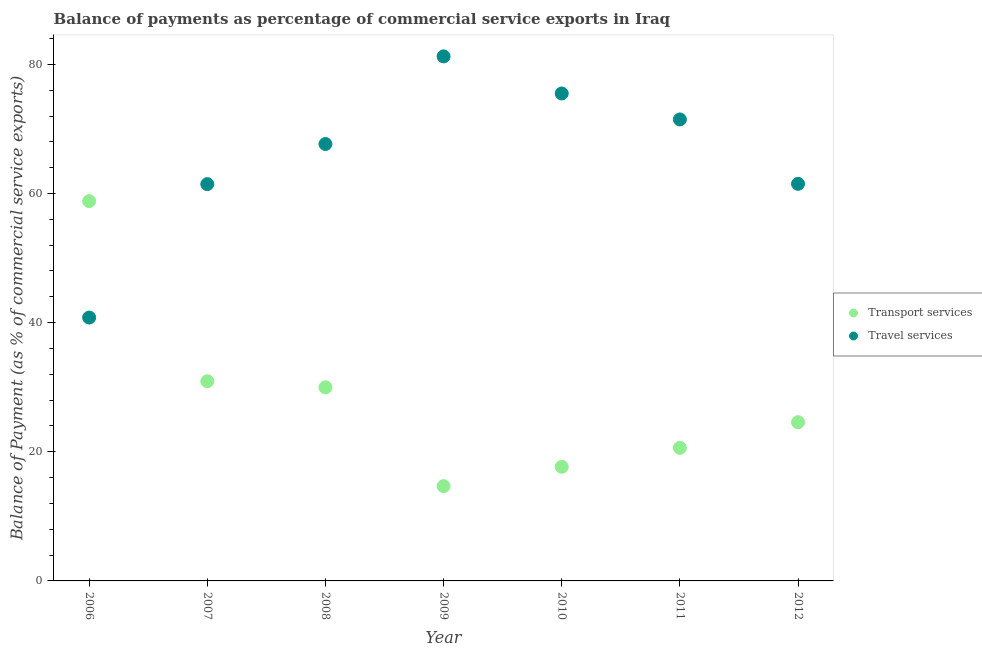What is the balance of payments of transport services in 2007?
Keep it short and to the point. 30.92. Across all years, what is the maximum balance of payments of travel services?
Provide a short and direct response. 81.24. Across all years, what is the minimum balance of payments of travel services?
Make the answer very short. 40.79. In which year was the balance of payments of transport services maximum?
Provide a succinct answer. 2006. In which year was the balance of payments of travel services minimum?
Your response must be concise. 2006. What is the total balance of payments of travel services in the graph?
Provide a short and direct response. 459.59. What is the difference between the balance of payments of transport services in 2007 and that in 2010?
Offer a very short reply. 13.25. What is the difference between the balance of payments of travel services in 2010 and the balance of payments of transport services in 2006?
Ensure brevity in your answer.  16.67. What is the average balance of payments of travel services per year?
Your response must be concise. 65.66. In the year 2012, what is the difference between the balance of payments of transport services and balance of payments of travel services?
Your answer should be very brief. -36.92. What is the ratio of the balance of payments of transport services in 2009 to that in 2011?
Make the answer very short. 0.71. Is the balance of payments of travel services in 2008 less than that in 2012?
Your answer should be very brief. No. What is the difference between the highest and the second highest balance of payments of travel services?
Ensure brevity in your answer.  5.75. What is the difference between the highest and the lowest balance of payments of travel services?
Your answer should be very brief. 40.45. Does the balance of payments of travel services monotonically increase over the years?
Your response must be concise. No. Is the balance of payments of transport services strictly greater than the balance of payments of travel services over the years?
Your answer should be compact. No. What is the difference between two consecutive major ticks on the Y-axis?
Provide a short and direct response. 20. Are the values on the major ticks of Y-axis written in scientific E-notation?
Provide a succinct answer. No. Does the graph contain any zero values?
Offer a very short reply. No. Where does the legend appear in the graph?
Ensure brevity in your answer.  Center right. What is the title of the graph?
Provide a succinct answer. Balance of payments as percentage of commercial service exports in Iraq. What is the label or title of the X-axis?
Give a very brief answer. Year. What is the label or title of the Y-axis?
Your response must be concise. Balance of Payment (as % of commercial service exports). What is the Balance of Payment (as % of commercial service exports) in Transport services in 2006?
Offer a terse response. 58.82. What is the Balance of Payment (as % of commercial service exports) in Travel services in 2006?
Provide a succinct answer. 40.79. What is the Balance of Payment (as % of commercial service exports) in Transport services in 2007?
Give a very brief answer. 30.92. What is the Balance of Payment (as % of commercial service exports) of Travel services in 2007?
Provide a succinct answer. 61.45. What is the Balance of Payment (as % of commercial service exports) of Transport services in 2008?
Keep it short and to the point. 29.98. What is the Balance of Payment (as % of commercial service exports) in Travel services in 2008?
Ensure brevity in your answer.  67.66. What is the Balance of Payment (as % of commercial service exports) in Transport services in 2009?
Give a very brief answer. 14.68. What is the Balance of Payment (as % of commercial service exports) in Travel services in 2009?
Ensure brevity in your answer.  81.24. What is the Balance of Payment (as % of commercial service exports) of Transport services in 2010?
Make the answer very short. 17.68. What is the Balance of Payment (as % of commercial service exports) of Travel services in 2010?
Your response must be concise. 75.49. What is the Balance of Payment (as % of commercial service exports) of Transport services in 2011?
Provide a short and direct response. 20.61. What is the Balance of Payment (as % of commercial service exports) of Travel services in 2011?
Provide a succinct answer. 71.47. What is the Balance of Payment (as % of commercial service exports) in Transport services in 2012?
Offer a very short reply. 24.58. What is the Balance of Payment (as % of commercial service exports) of Travel services in 2012?
Offer a very short reply. 61.5. Across all years, what is the maximum Balance of Payment (as % of commercial service exports) in Transport services?
Your answer should be very brief. 58.82. Across all years, what is the maximum Balance of Payment (as % of commercial service exports) of Travel services?
Your response must be concise. 81.24. Across all years, what is the minimum Balance of Payment (as % of commercial service exports) in Transport services?
Ensure brevity in your answer.  14.68. Across all years, what is the minimum Balance of Payment (as % of commercial service exports) in Travel services?
Provide a short and direct response. 40.79. What is the total Balance of Payment (as % of commercial service exports) in Transport services in the graph?
Provide a succinct answer. 197.27. What is the total Balance of Payment (as % of commercial service exports) in Travel services in the graph?
Provide a succinct answer. 459.59. What is the difference between the Balance of Payment (as % of commercial service exports) in Transport services in 2006 and that in 2007?
Your response must be concise. 27.89. What is the difference between the Balance of Payment (as % of commercial service exports) of Travel services in 2006 and that in 2007?
Offer a terse response. -20.66. What is the difference between the Balance of Payment (as % of commercial service exports) in Transport services in 2006 and that in 2008?
Make the answer very short. 28.83. What is the difference between the Balance of Payment (as % of commercial service exports) in Travel services in 2006 and that in 2008?
Ensure brevity in your answer.  -26.88. What is the difference between the Balance of Payment (as % of commercial service exports) of Transport services in 2006 and that in 2009?
Make the answer very short. 44.13. What is the difference between the Balance of Payment (as % of commercial service exports) of Travel services in 2006 and that in 2009?
Offer a very short reply. -40.45. What is the difference between the Balance of Payment (as % of commercial service exports) in Transport services in 2006 and that in 2010?
Provide a succinct answer. 41.14. What is the difference between the Balance of Payment (as % of commercial service exports) in Travel services in 2006 and that in 2010?
Make the answer very short. -34.7. What is the difference between the Balance of Payment (as % of commercial service exports) of Transport services in 2006 and that in 2011?
Give a very brief answer. 38.21. What is the difference between the Balance of Payment (as % of commercial service exports) in Travel services in 2006 and that in 2011?
Give a very brief answer. -30.68. What is the difference between the Balance of Payment (as % of commercial service exports) of Transport services in 2006 and that in 2012?
Your response must be concise. 34.24. What is the difference between the Balance of Payment (as % of commercial service exports) of Travel services in 2006 and that in 2012?
Keep it short and to the point. -20.71. What is the difference between the Balance of Payment (as % of commercial service exports) in Transport services in 2007 and that in 2008?
Keep it short and to the point. 0.94. What is the difference between the Balance of Payment (as % of commercial service exports) of Travel services in 2007 and that in 2008?
Your answer should be very brief. -6.21. What is the difference between the Balance of Payment (as % of commercial service exports) in Transport services in 2007 and that in 2009?
Provide a short and direct response. 16.24. What is the difference between the Balance of Payment (as % of commercial service exports) of Travel services in 2007 and that in 2009?
Offer a terse response. -19.79. What is the difference between the Balance of Payment (as % of commercial service exports) in Transport services in 2007 and that in 2010?
Your response must be concise. 13.25. What is the difference between the Balance of Payment (as % of commercial service exports) in Travel services in 2007 and that in 2010?
Keep it short and to the point. -14.04. What is the difference between the Balance of Payment (as % of commercial service exports) of Transport services in 2007 and that in 2011?
Ensure brevity in your answer.  10.31. What is the difference between the Balance of Payment (as % of commercial service exports) of Travel services in 2007 and that in 2011?
Keep it short and to the point. -10.02. What is the difference between the Balance of Payment (as % of commercial service exports) in Transport services in 2007 and that in 2012?
Provide a succinct answer. 6.35. What is the difference between the Balance of Payment (as % of commercial service exports) of Travel services in 2007 and that in 2012?
Provide a succinct answer. -0.05. What is the difference between the Balance of Payment (as % of commercial service exports) in Transport services in 2008 and that in 2009?
Offer a very short reply. 15.3. What is the difference between the Balance of Payment (as % of commercial service exports) of Travel services in 2008 and that in 2009?
Make the answer very short. -13.57. What is the difference between the Balance of Payment (as % of commercial service exports) in Transport services in 2008 and that in 2010?
Ensure brevity in your answer.  12.31. What is the difference between the Balance of Payment (as % of commercial service exports) of Travel services in 2008 and that in 2010?
Your response must be concise. -7.83. What is the difference between the Balance of Payment (as % of commercial service exports) of Transport services in 2008 and that in 2011?
Provide a succinct answer. 9.37. What is the difference between the Balance of Payment (as % of commercial service exports) of Travel services in 2008 and that in 2011?
Provide a short and direct response. -3.81. What is the difference between the Balance of Payment (as % of commercial service exports) in Transport services in 2008 and that in 2012?
Keep it short and to the point. 5.41. What is the difference between the Balance of Payment (as % of commercial service exports) of Travel services in 2008 and that in 2012?
Your response must be concise. 6.16. What is the difference between the Balance of Payment (as % of commercial service exports) of Transport services in 2009 and that in 2010?
Ensure brevity in your answer.  -2.99. What is the difference between the Balance of Payment (as % of commercial service exports) of Travel services in 2009 and that in 2010?
Offer a terse response. 5.75. What is the difference between the Balance of Payment (as % of commercial service exports) in Transport services in 2009 and that in 2011?
Keep it short and to the point. -5.93. What is the difference between the Balance of Payment (as % of commercial service exports) of Travel services in 2009 and that in 2011?
Your answer should be compact. 9.77. What is the difference between the Balance of Payment (as % of commercial service exports) in Transport services in 2009 and that in 2012?
Make the answer very short. -9.89. What is the difference between the Balance of Payment (as % of commercial service exports) of Travel services in 2009 and that in 2012?
Give a very brief answer. 19.74. What is the difference between the Balance of Payment (as % of commercial service exports) in Transport services in 2010 and that in 2011?
Give a very brief answer. -2.94. What is the difference between the Balance of Payment (as % of commercial service exports) of Travel services in 2010 and that in 2011?
Offer a very short reply. 4.02. What is the difference between the Balance of Payment (as % of commercial service exports) of Transport services in 2010 and that in 2012?
Offer a very short reply. -6.9. What is the difference between the Balance of Payment (as % of commercial service exports) of Travel services in 2010 and that in 2012?
Give a very brief answer. 13.99. What is the difference between the Balance of Payment (as % of commercial service exports) in Transport services in 2011 and that in 2012?
Your answer should be very brief. -3.97. What is the difference between the Balance of Payment (as % of commercial service exports) in Travel services in 2011 and that in 2012?
Provide a short and direct response. 9.97. What is the difference between the Balance of Payment (as % of commercial service exports) in Transport services in 2006 and the Balance of Payment (as % of commercial service exports) in Travel services in 2007?
Give a very brief answer. -2.63. What is the difference between the Balance of Payment (as % of commercial service exports) in Transport services in 2006 and the Balance of Payment (as % of commercial service exports) in Travel services in 2008?
Offer a terse response. -8.85. What is the difference between the Balance of Payment (as % of commercial service exports) in Transport services in 2006 and the Balance of Payment (as % of commercial service exports) in Travel services in 2009?
Offer a terse response. -22.42. What is the difference between the Balance of Payment (as % of commercial service exports) of Transport services in 2006 and the Balance of Payment (as % of commercial service exports) of Travel services in 2010?
Offer a terse response. -16.67. What is the difference between the Balance of Payment (as % of commercial service exports) of Transport services in 2006 and the Balance of Payment (as % of commercial service exports) of Travel services in 2011?
Give a very brief answer. -12.65. What is the difference between the Balance of Payment (as % of commercial service exports) in Transport services in 2006 and the Balance of Payment (as % of commercial service exports) in Travel services in 2012?
Give a very brief answer. -2.68. What is the difference between the Balance of Payment (as % of commercial service exports) of Transport services in 2007 and the Balance of Payment (as % of commercial service exports) of Travel services in 2008?
Your answer should be compact. -36.74. What is the difference between the Balance of Payment (as % of commercial service exports) in Transport services in 2007 and the Balance of Payment (as % of commercial service exports) in Travel services in 2009?
Offer a terse response. -50.31. What is the difference between the Balance of Payment (as % of commercial service exports) of Transport services in 2007 and the Balance of Payment (as % of commercial service exports) of Travel services in 2010?
Your response must be concise. -44.57. What is the difference between the Balance of Payment (as % of commercial service exports) of Transport services in 2007 and the Balance of Payment (as % of commercial service exports) of Travel services in 2011?
Your response must be concise. -40.55. What is the difference between the Balance of Payment (as % of commercial service exports) in Transport services in 2007 and the Balance of Payment (as % of commercial service exports) in Travel services in 2012?
Your answer should be very brief. -30.58. What is the difference between the Balance of Payment (as % of commercial service exports) in Transport services in 2008 and the Balance of Payment (as % of commercial service exports) in Travel services in 2009?
Offer a terse response. -51.25. What is the difference between the Balance of Payment (as % of commercial service exports) of Transport services in 2008 and the Balance of Payment (as % of commercial service exports) of Travel services in 2010?
Keep it short and to the point. -45.51. What is the difference between the Balance of Payment (as % of commercial service exports) of Transport services in 2008 and the Balance of Payment (as % of commercial service exports) of Travel services in 2011?
Your answer should be very brief. -41.48. What is the difference between the Balance of Payment (as % of commercial service exports) in Transport services in 2008 and the Balance of Payment (as % of commercial service exports) in Travel services in 2012?
Make the answer very short. -31.51. What is the difference between the Balance of Payment (as % of commercial service exports) of Transport services in 2009 and the Balance of Payment (as % of commercial service exports) of Travel services in 2010?
Offer a terse response. -60.81. What is the difference between the Balance of Payment (as % of commercial service exports) of Transport services in 2009 and the Balance of Payment (as % of commercial service exports) of Travel services in 2011?
Provide a short and direct response. -56.79. What is the difference between the Balance of Payment (as % of commercial service exports) of Transport services in 2009 and the Balance of Payment (as % of commercial service exports) of Travel services in 2012?
Your answer should be very brief. -46.82. What is the difference between the Balance of Payment (as % of commercial service exports) in Transport services in 2010 and the Balance of Payment (as % of commercial service exports) in Travel services in 2011?
Your answer should be compact. -53.79. What is the difference between the Balance of Payment (as % of commercial service exports) in Transport services in 2010 and the Balance of Payment (as % of commercial service exports) in Travel services in 2012?
Keep it short and to the point. -43.82. What is the difference between the Balance of Payment (as % of commercial service exports) of Transport services in 2011 and the Balance of Payment (as % of commercial service exports) of Travel services in 2012?
Give a very brief answer. -40.89. What is the average Balance of Payment (as % of commercial service exports) of Transport services per year?
Keep it short and to the point. 28.18. What is the average Balance of Payment (as % of commercial service exports) in Travel services per year?
Provide a short and direct response. 65.66. In the year 2006, what is the difference between the Balance of Payment (as % of commercial service exports) of Transport services and Balance of Payment (as % of commercial service exports) of Travel services?
Give a very brief answer. 18.03. In the year 2007, what is the difference between the Balance of Payment (as % of commercial service exports) in Transport services and Balance of Payment (as % of commercial service exports) in Travel services?
Offer a very short reply. -30.53. In the year 2008, what is the difference between the Balance of Payment (as % of commercial service exports) of Transport services and Balance of Payment (as % of commercial service exports) of Travel services?
Your answer should be very brief. -37.68. In the year 2009, what is the difference between the Balance of Payment (as % of commercial service exports) in Transport services and Balance of Payment (as % of commercial service exports) in Travel services?
Give a very brief answer. -66.55. In the year 2010, what is the difference between the Balance of Payment (as % of commercial service exports) in Transport services and Balance of Payment (as % of commercial service exports) in Travel services?
Your response must be concise. -57.81. In the year 2011, what is the difference between the Balance of Payment (as % of commercial service exports) of Transport services and Balance of Payment (as % of commercial service exports) of Travel services?
Offer a very short reply. -50.86. In the year 2012, what is the difference between the Balance of Payment (as % of commercial service exports) in Transport services and Balance of Payment (as % of commercial service exports) in Travel services?
Provide a short and direct response. -36.92. What is the ratio of the Balance of Payment (as % of commercial service exports) in Transport services in 2006 to that in 2007?
Your answer should be compact. 1.9. What is the ratio of the Balance of Payment (as % of commercial service exports) of Travel services in 2006 to that in 2007?
Offer a very short reply. 0.66. What is the ratio of the Balance of Payment (as % of commercial service exports) in Transport services in 2006 to that in 2008?
Keep it short and to the point. 1.96. What is the ratio of the Balance of Payment (as % of commercial service exports) of Travel services in 2006 to that in 2008?
Provide a short and direct response. 0.6. What is the ratio of the Balance of Payment (as % of commercial service exports) of Transport services in 2006 to that in 2009?
Make the answer very short. 4.01. What is the ratio of the Balance of Payment (as % of commercial service exports) of Travel services in 2006 to that in 2009?
Make the answer very short. 0.5. What is the ratio of the Balance of Payment (as % of commercial service exports) of Transport services in 2006 to that in 2010?
Your answer should be very brief. 3.33. What is the ratio of the Balance of Payment (as % of commercial service exports) of Travel services in 2006 to that in 2010?
Offer a terse response. 0.54. What is the ratio of the Balance of Payment (as % of commercial service exports) of Transport services in 2006 to that in 2011?
Your answer should be very brief. 2.85. What is the ratio of the Balance of Payment (as % of commercial service exports) in Travel services in 2006 to that in 2011?
Your answer should be compact. 0.57. What is the ratio of the Balance of Payment (as % of commercial service exports) of Transport services in 2006 to that in 2012?
Give a very brief answer. 2.39. What is the ratio of the Balance of Payment (as % of commercial service exports) in Travel services in 2006 to that in 2012?
Your response must be concise. 0.66. What is the ratio of the Balance of Payment (as % of commercial service exports) in Transport services in 2007 to that in 2008?
Give a very brief answer. 1.03. What is the ratio of the Balance of Payment (as % of commercial service exports) of Travel services in 2007 to that in 2008?
Your response must be concise. 0.91. What is the ratio of the Balance of Payment (as % of commercial service exports) in Transport services in 2007 to that in 2009?
Your response must be concise. 2.11. What is the ratio of the Balance of Payment (as % of commercial service exports) of Travel services in 2007 to that in 2009?
Ensure brevity in your answer.  0.76. What is the ratio of the Balance of Payment (as % of commercial service exports) of Transport services in 2007 to that in 2010?
Make the answer very short. 1.75. What is the ratio of the Balance of Payment (as % of commercial service exports) in Travel services in 2007 to that in 2010?
Give a very brief answer. 0.81. What is the ratio of the Balance of Payment (as % of commercial service exports) in Transport services in 2007 to that in 2011?
Offer a terse response. 1.5. What is the ratio of the Balance of Payment (as % of commercial service exports) of Travel services in 2007 to that in 2011?
Your answer should be very brief. 0.86. What is the ratio of the Balance of Payment (as % of commercial service exports) in Transport services in 2007 to that in 2012?
Your response must be concise. 1.26. What is the ratio of the Balance of Payment (as % of commercial service exports) of Travel services in 2007 to that in 2012?
Make the answer very short. 1. What is the ratio of the Balance of Payment (as % of commercial service exports) of Transport services in 2008 to that in 2009?
Offer a very short reply. 2.04. What is the ratio of the Balance of Payment (as % of commercial service exports) of Travel services in 2008 to that in 2009?
Make the answer very short. 0.83. What is the ratio of the Balance of Payment (as % of commercial service exports) in Transport services in 2008 to that in 2010?
Your answer should be compact. 1.7. What is the ratio of the Balance of Payment (as % of commercial service exports) in Travel services in 2008 to that in 2010?
Give a very brief answer. 0.9. What is the ratio of the Balance of Payment (as % of commercial service exports) in Transport services in 2008 to that in 2011?
Keep it short and to the point. 1.45. What is the ratio of the Balance of Payment (as % of commercial service exports) in Travel services in 2008 to that in 2011?
Your answer should be compact. 0.95. What is the ratio of the Balance of Payment (as % of commercial service exports) in Transport services in 2008 to that in 2012?
Give a very brief answer. 1.22. What is the ratio of the Balance of Payment (as % of commercial service exports) in Travel services in 2008 to that in 2012?
Offer a terse response. 1.1. What is the ratio of the Balance of Payment (as % of commercial service exports) of Transport services in 2009 to that in 2010?
Make the answer very short. 0.83. What is the ratio of the Balance of Payment (as % of commercial service exports) of Travel services in 2009 to that in 2010?
Make the answer very short. 1.08. What is the ratio of the Balance of Payment (as % of commercial service exports) in Transport services in 2009 to that in 2011?
Provide a short and direct response. 0.71. What is the ratio of the Balance of Payment (as % of commercial service exports) of Travel services in 2009 to that in 2011?
Your response must be concise. 1.14. What is the ratio of the Balance of Payment (as % of commercial service exports) of Transport services in 2009 to that in 2012?
Ensure brevity in your answer.  0.6. What is the ratio of the Balance of Payment (as % of commercial service exports) in Travel services in 2009 to that in 2012?
Offer a very short reply. 1.32. What is the ratio of the Balance of Payment (as % of commercial service exports) of Transport services in 2010 to that in 2011?
Provide a succinct answer. 0.86. What is the ratio of the Balance of Payment (as % of commercial service exports) in Travel services in 2010 to that in 2011?
Ensure brevity in your answer.  1.06. What is the ratio of the Balance of Payment (as % of commercial service exports) of Transport services in 2010 to that in 2012?
Make the answer very short. 0.72. What is the ratio of the Balance of Payment (as % of commercial service exports) of Travel services in 2010 to that in 2012?
Give a very brief answer. 1.23. What is the ratio of the Balance of Payment (as % of commercial service exports) in Transport services in 2011 to that in 2012?
Your answer should be very brief. 0.84. What is the ratio of the Balance of Payment (as % of commercial service exports) of Travel services in 2011 to that in 2012?
Offer a very short reply. 1.16. What is the difference between the highest and the second highest Balance of Payment (as % of commercial service exports) of Transport services?
Provide a short and direct response. 27.89. What is the difference between the highest and the second highest Balance of Payment (as % of commercial service exports) in Travel services?
Your answer should be compact. 5.75. What is the difference between the highest and the lowest Balance of Payment (as % of commercial service exports) in Transport services?
Your answer should be compact. 44.13. What is the difference between the highest and the lowest Balance of Payment (as % of commercial service exports) in Travel services?
Offer a very short reply. 40.45. 